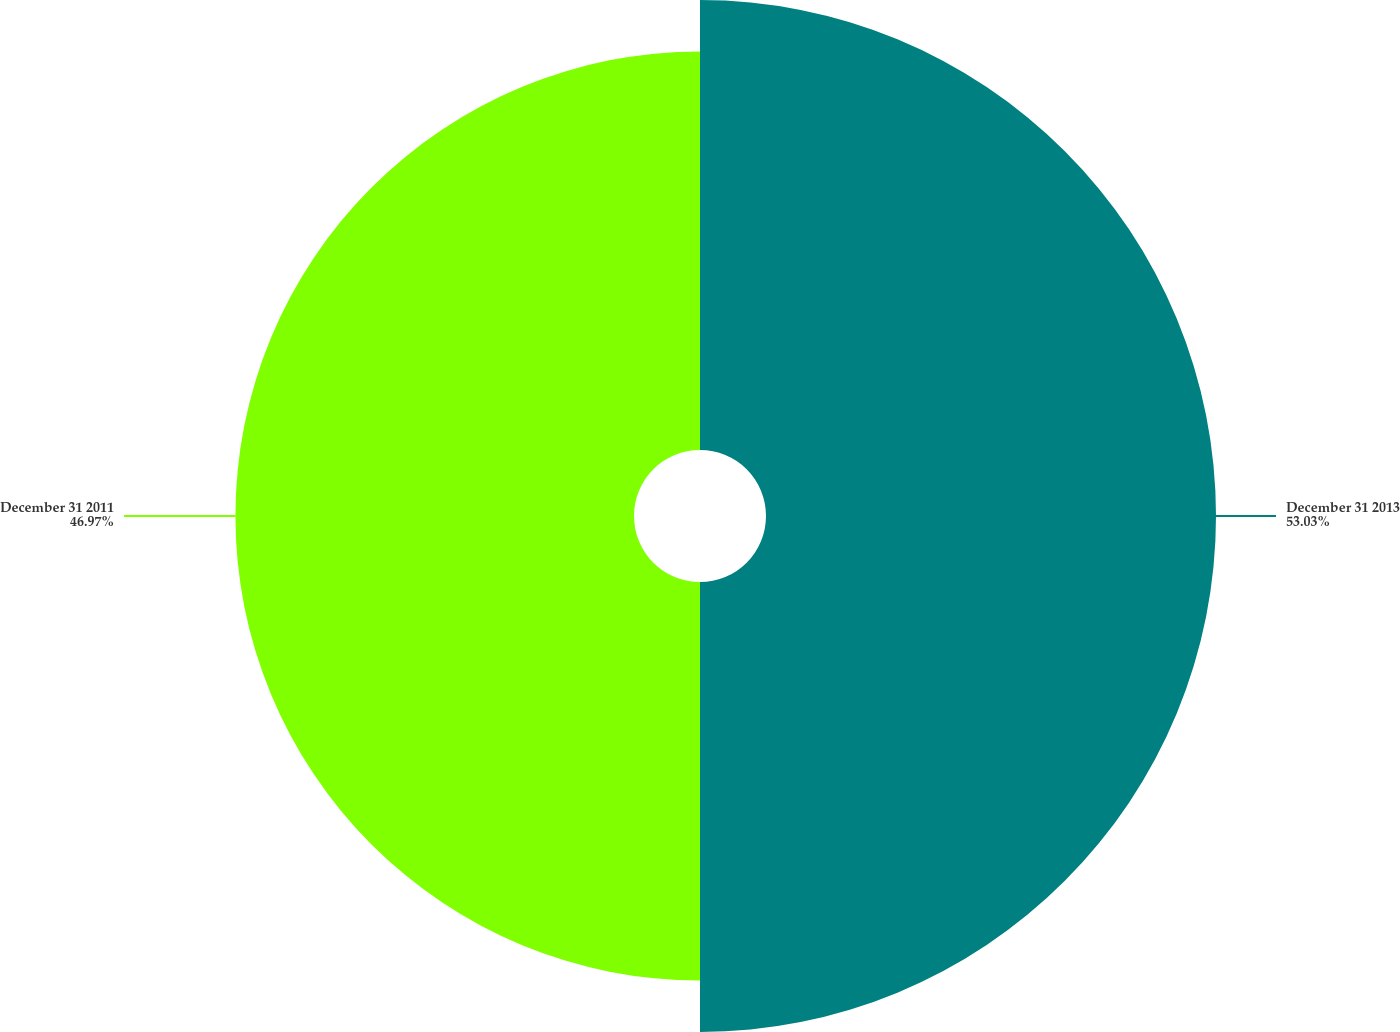Convert chart. <chart><loc_0><loc_0><loc_500><loc_500><pie_chart><fcel>December 31 2013<fcel>December 31 2011<nl><fcel>53.03%<fcel>46.97%<nl></chart> 